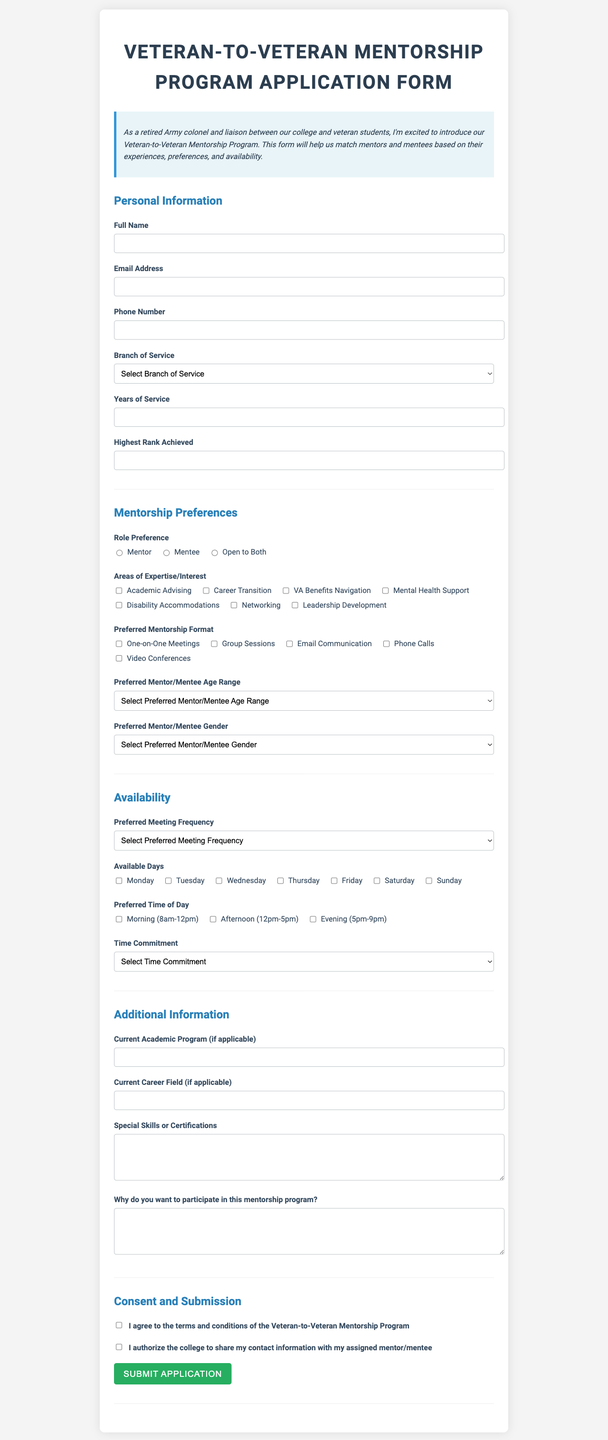what is the title of the document? The title of the document is provided at the top of the form.
Answer: Veteran-to-Veteran Mentorship Program Application Form what is the required field for personal information? The personal information section lists several fields, but only the required ones are considered.
Answer: Full Name, Email Address, Phone Number, Branch of Service, Years of Service, Highest Rank Achieved what are the preferred mentorship formats available? The document lists various options under mentorship preferences for how meetings can occur.
Answer: One-on-One Meetings, Group Sessions, Email Communication, Phone Calls, Video Conferences what options are available for preferred meeting frequency? The availability section specifies how often meetings can be scheduled according to the preferences indicated.
Answer: Weekly, Bi-weekly, Monthly, Quarterly how many areas of expertise or interest can a participant select? The mentorship preferences allow participants to indicate multiple areas they are interested in.
Answer: Multiple (up to all listed options) what is the maximum commitment of time per month for participation? The form specifies how much time a participant is willing to commit in terms of hours per month.
Answer: 7+ hours per month which fields are optional in the additional information section? The section lists fields that are not mandatory for participation, indicating flexibility in what to provide.
Answer: Current Academic Program, Current Career Field, Special Skills or Certifications is a time commitment considered mandatory in the form? The form requires certain inputs to be completed by participants for successful submission.
Answer: Yes what do participants need to acknowledge before submitting their application? The consent and submission section outlines what the participants agree to before finalizing their application.
Answer: Agreement to terms and conditions, authorization of contact information sharing 